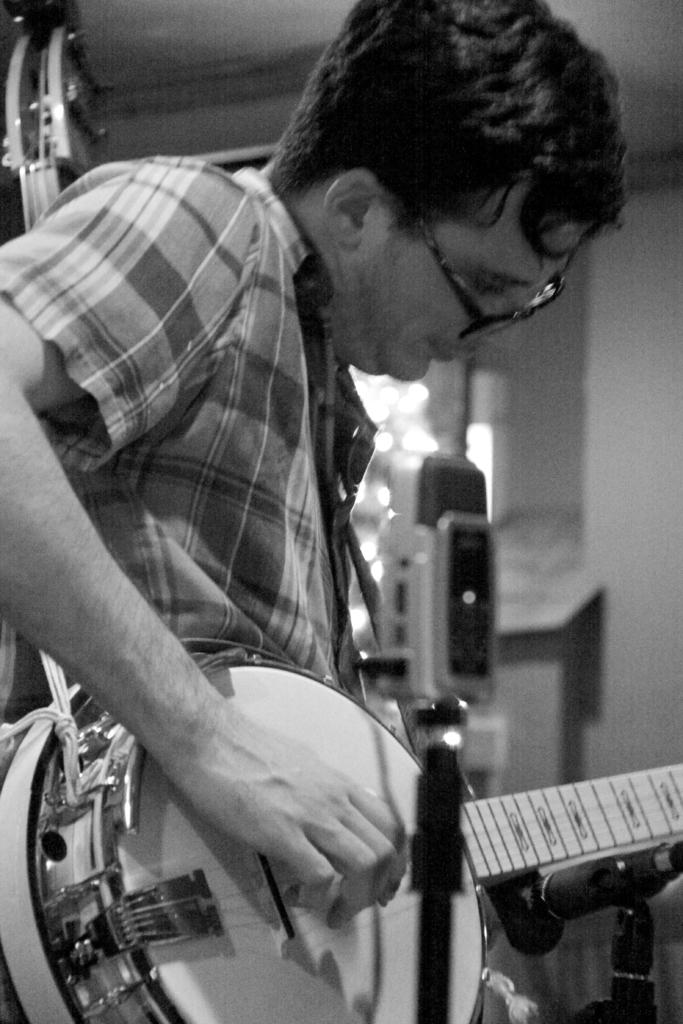What is the main subject of the image? There is a person in the image. What is the person doing in the image? The person is holding a musical instrument. What type of owl can be seen sitting on the person's shoulder in the image? There is no owl present in the image; the person is holding a musical instrument. What color is the ink used to write the lyrics on the sheet music in the image? There is no sheet music or ink present in the image; the person is simply holding a musical instrument. 